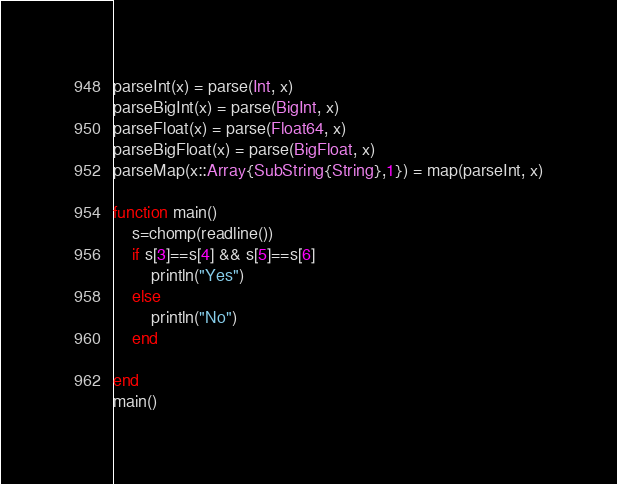Convert code to text. <code><loc_0><loc_0><loc_500><loc_500><_Julia_>parseInt(x) = parse(Int, x)
parseBigInt(x) = parse(BigInt, x)
parseFloat(x) = parse(Float64, x)
parseBigFloat(x) = parse(BigFloat, x)
parseMap(x::Array{SubString{String},1}) = map(parseInt, x)

function main()
    s=chomp(readline())
    if s[3]==s[4] && s[5]==s[6]
        println("Yes")
    else
        println("No")
    end

end
main()</code> 